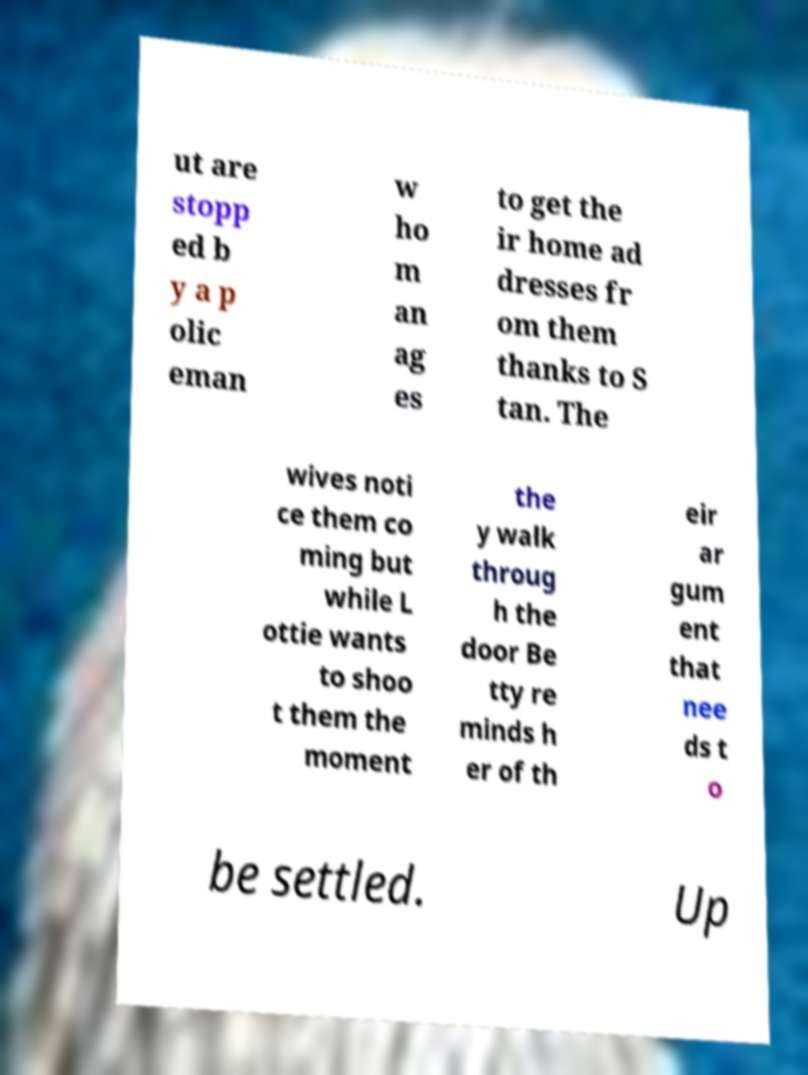Could you assist in decoding the text presented in this image and type it out clearly? ut are stopp ed b y a p olic eman w ho m an ag es to get the ir home ad dresses fr om them thanks to S tan. The wives noti ce them co ming but while L ottie wants to shoo t them the moment the y walk throug h the door Be tty re minds h er of th eir ar gum ent that nee ds t o be settled. Up 